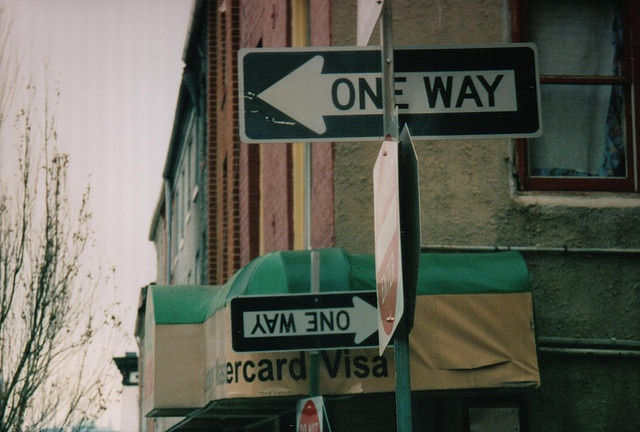Describe the objects in this image and their specific colors. I can see stop sign in darkgray, black, gray, and teal tones and stop sign in darkgray, black, gray, and darkgreen tones in this image. 